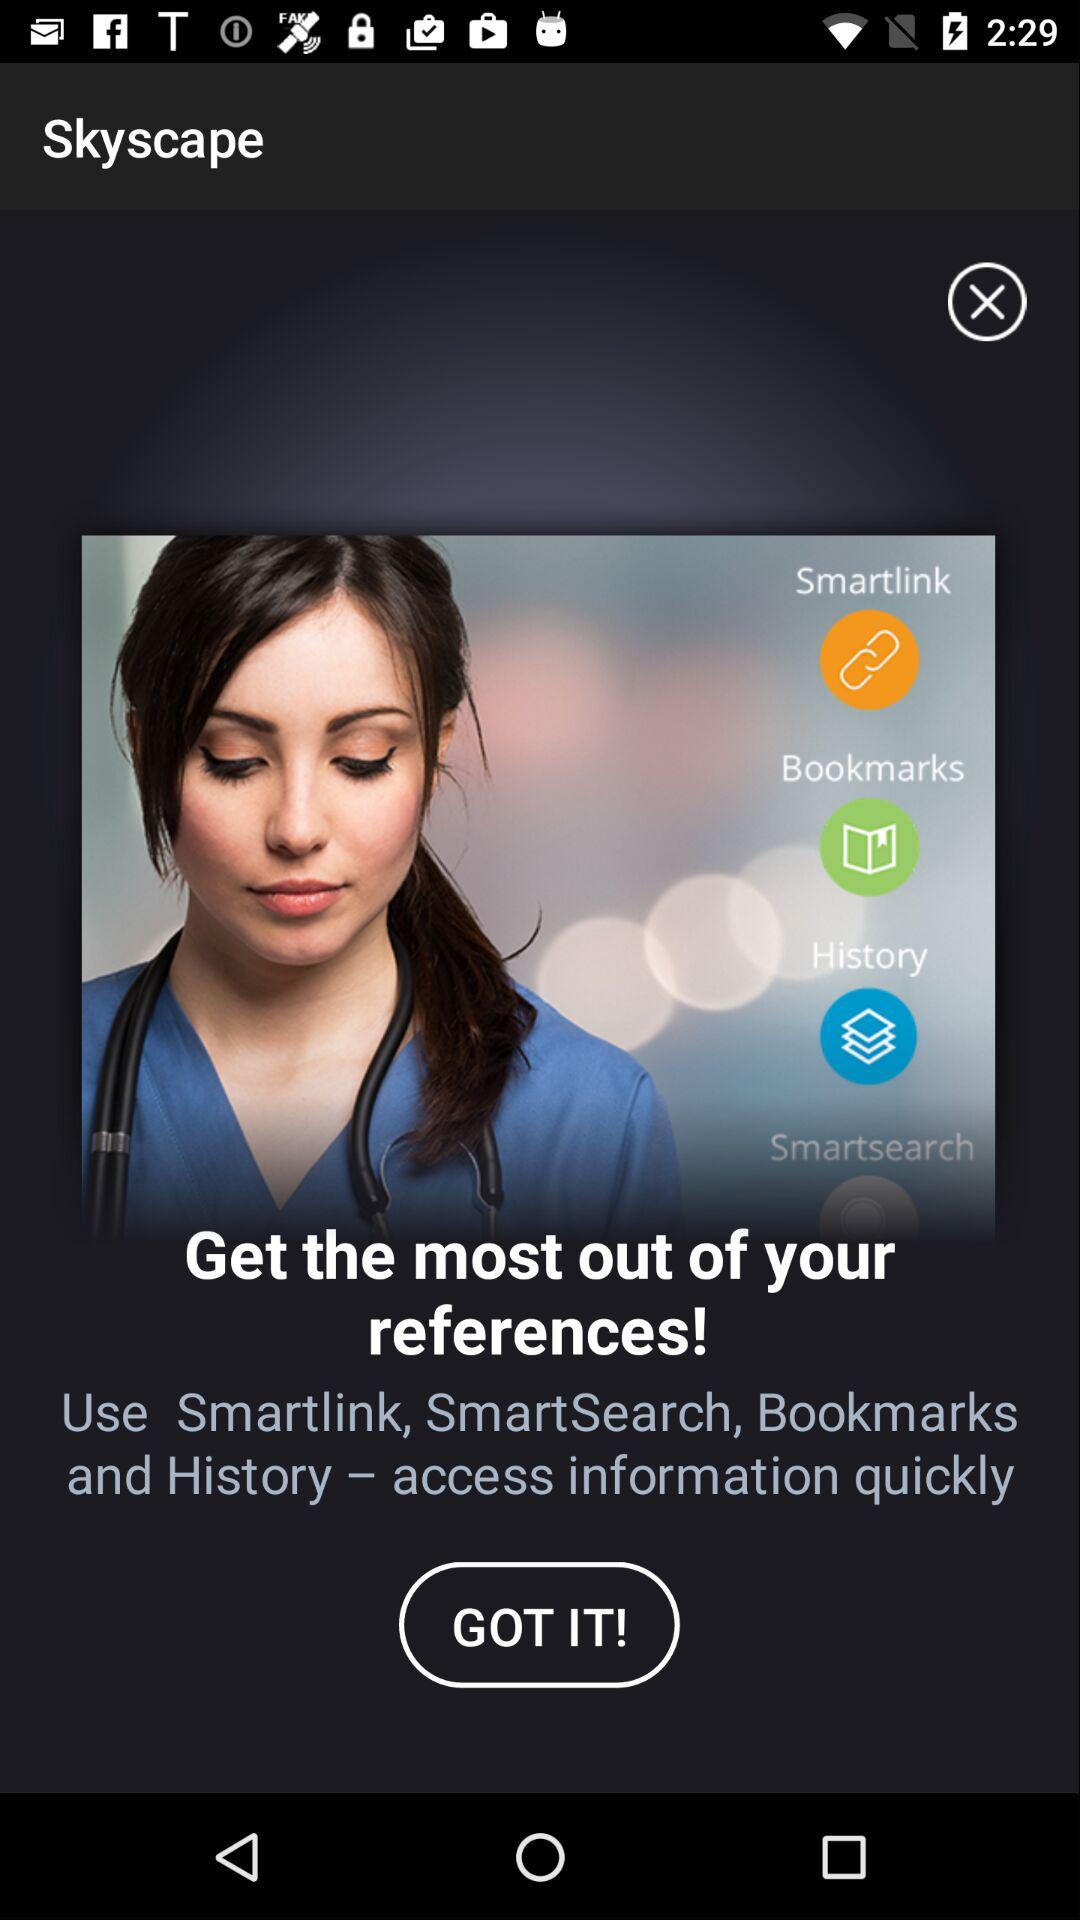What are the options available for quick access? The options available are "Smartlink", "Bookmarks", "History" and "Smartsearch". 